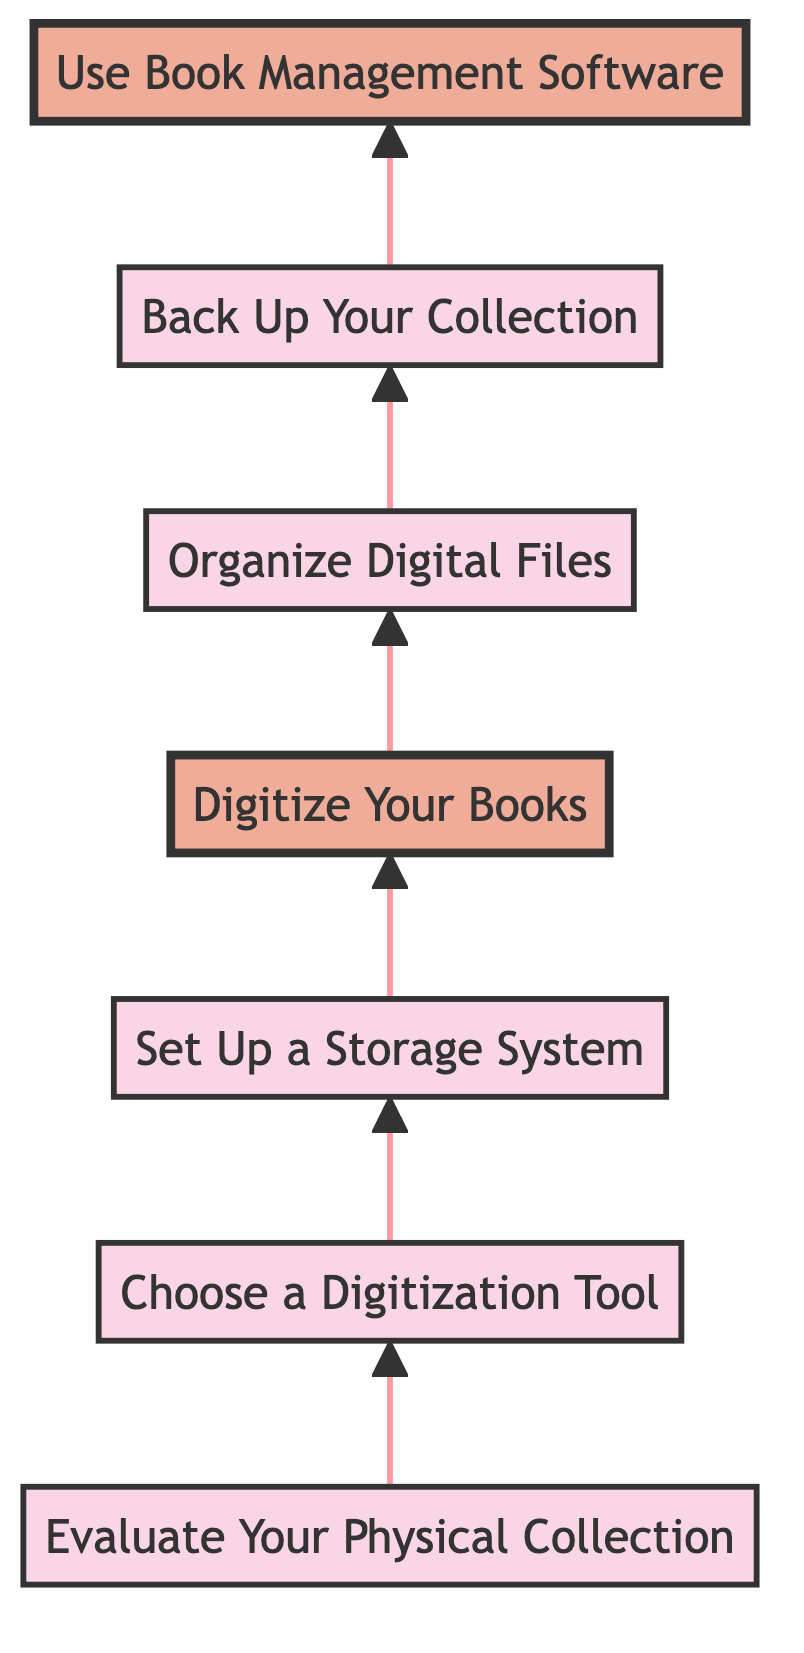What is the first step in the process? The first step is indicated at the bottom of the flow chart, which is "Evaluate Your Physical Collection."
Answer: Evaluate Your Physical Collection Which step comes after choosing a digitization tool? Following the "Choose a Digitization Tool" step, the next step in the diagram is "Set Up a Storage System," connected upward.
Answer: Set Up a Storage System How many steps are there in total? Counting all steps listed in the flow chart from bottom to top, there are seven steps in total.
Answer: Seven What step is emphasized by a bold font in the diagram? The step that is highlighted with a bold font is "Digitize Your Books," indicating its importance in the process.
Answer: Digitize Your Books Which steps are highlighted in the diagram? The highlighted steps, shown with a distinct font, are "Digitize Your Books" and "Use Book Management Software."
Answer: Digitize Your Books, Use Book Management Software What action needs to be taken immediately after organizing digital files? The action that follows "Organize Digital Files" is "Back Up Your Collection," indicating the process's continuity.
Answer: Back Up Your Collection If you start with evaluating your physical collection, what is the final step? Progressing through each step upward starting from "Evaluate Your Physical Collection," the final step is "Use Book Management Software."
Answer: Use Book Management Software What is the relationship between digitizing books and organizing digital files? The relationship is sequential; after "Digitize Your Books," the next step is directly related and is "Organize Digital Files."
Answer: Sequential relationship Which tool is suggested for digitization? The diagram suggests tools like "Fujitsu ScanSnap" or "Google Drive's scan feature" for digitization.
Answer: Fujitsu ScanSnap or Google Drive's scan feature What should you do after setting up a storage system? After "Set Up a Storage System," the next action is to "Digitize Your Books," maintaining the flow of the process.
Answer: Digitize Your Books 